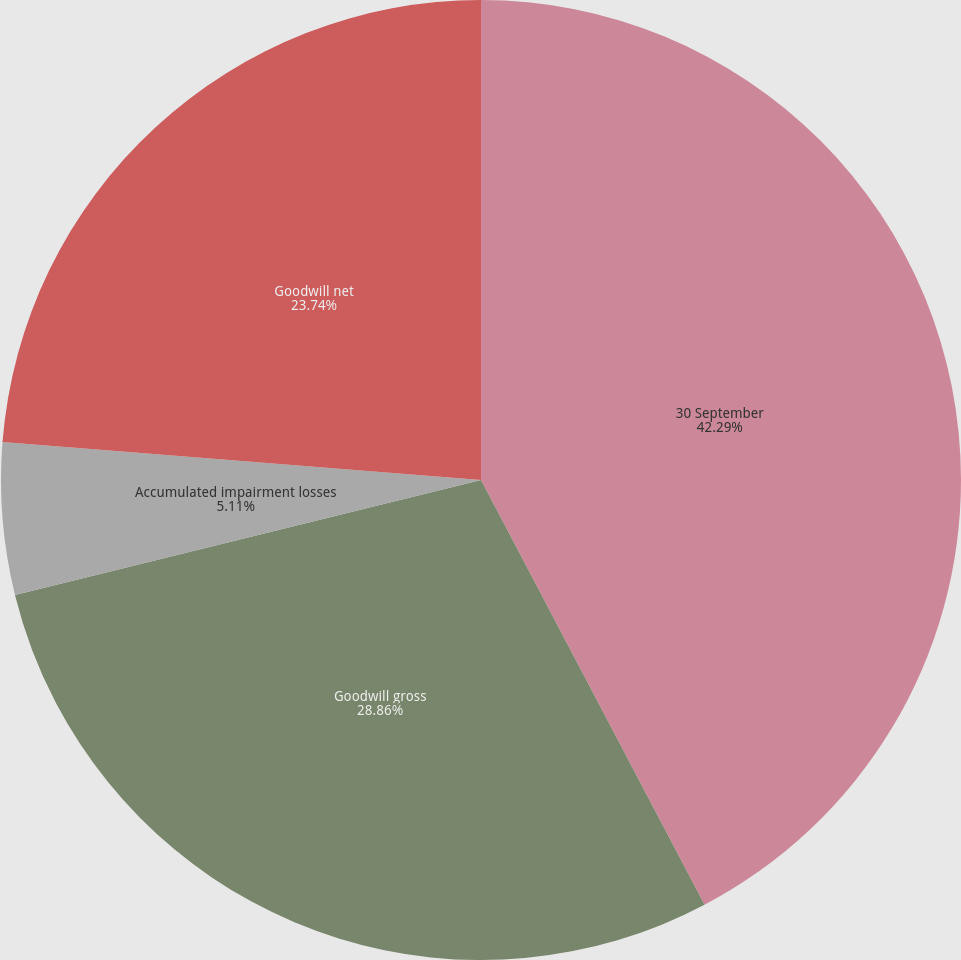Convert chart to OTSL. <chart><loc_0><loc_0><loc_500><loc_500><pie_chart><fcel>30 September<fcel>Goodwill gross<fcel>Accumulated impairment losses<fcel>Goodwill net<nl><fcel>42.29%<fcel>28.86%<fcel>5.11%<fcel>23.74%<nl></chart> 